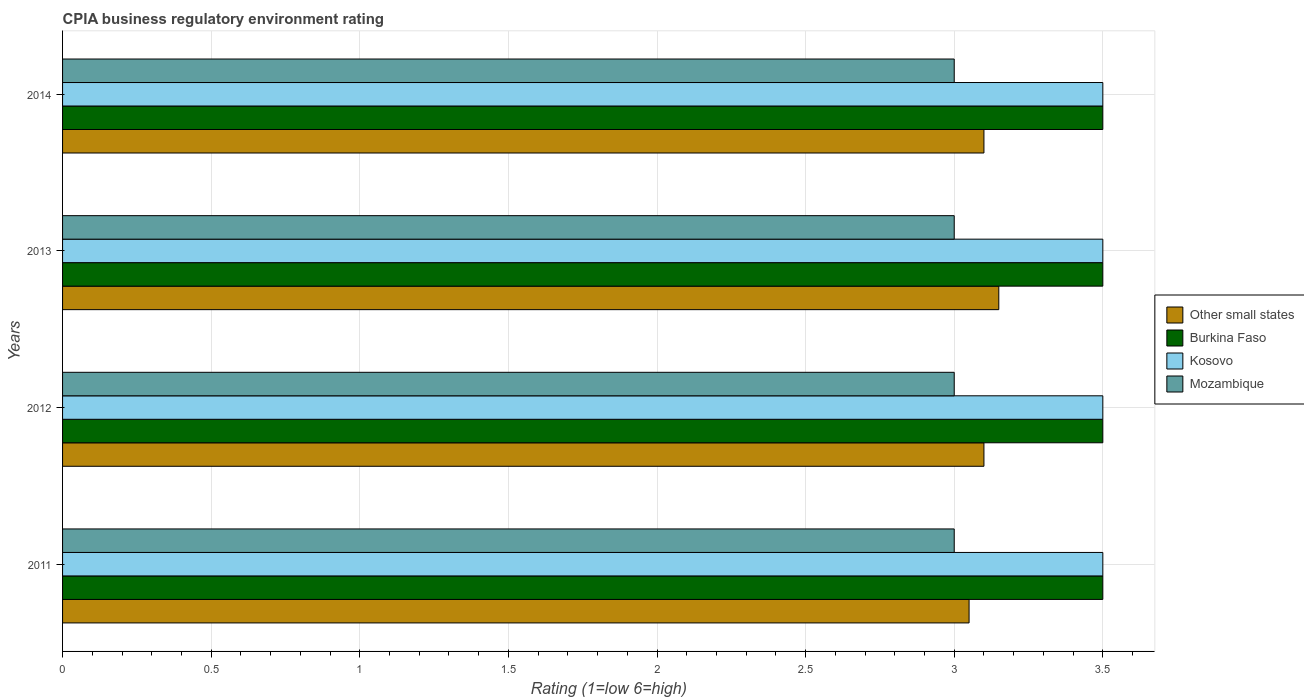How many different coloured bars are there?
Provide a short and direct response. 4. How many groups of bars are there?
Offer a terse response. 4. Are the number of bars per tick equal to the number of legend labels?
Your response must be concise. Yes. In how many cases, is the number of bars for a given year not equal to the number of legend labels?
Your answer should be compact. 0. Across all years, what is the maximum CPIA rating in Burkina Faso?
Your response must be concise. 3.5. Across all years, what is the minimum CPIA rating in Other small states?
Make the answer very short. 3.05. In which year was the CPIA rating in Mozambique maximum?
Your answer should be very brief. 2011. What is the total CPIA rating in Burkina Faso in the graph?
Your answer should be compact. 14. What is the difference between the CPIA rating in Burkina Faso in 2012 and that in 2013?
Keep it short and to the point. 0. What is the difference between the CPIA rating in Mozambique in 2011 and the CPIA rating in Other small states in 2012?
Offer a very short reply. -0.1. In the year 2011, what is the difference between the CPIA rating in Other small states and CPIA rating in Burkina Faso?
Offer a very short reply. -0.45. In how many years, is the CPIA rating in Mozambique greater than 1.1 ?
Your response must be concise. 4. Is the CPIA rating in Burkina Faso in 2012 less than that in 2013?
Offer a very short reply. No. Is the difference between the CPIA rating in Other small states in 2011 and 2014 greater than the difference between the CPIA rating in Burkina Faso in 2011 and 2014?
Give a very brief answer. No. What is the difference between the highest and the second highest CPIA rating in Burkina Faso?
Give a very brief answer. 0. What is the difference between the highest and the lowest CPIA rating in Kosovo?
Provide a short and direct response. 0. Is it the case that in every year, the sum of the CPIA rating in Other small states and CPIA rating in Burkina Faso is greater than the sum of CPIA rating in Kosovo and CPIA rating in Mozambique?
Ensure brevity in your answer.  No. What does the 2nd bar from the top in 2014 represents?
Keep it short and to the point. Kosovo. What does the 2nd bar from the bottom in 2011 represents?
Ensure brevity in your answer.  Burkina Faso. Is it the case that in every year, the sum of the CPIA rating in Burkina Faso and CPIA rating in Other small states is greater than the CPIA rating in Kosovo?
Your answer should be very brief. Yes. How many bars are there?
Offer a terse response. 16. Does the graph contain any zero values?
Ensure brevity in your answer.  No. Does the graph contain grids?
Keep it short and to the point. Yes. How are the legend labels stacked?
Provide a short and direct response. Vertical. What is the title of the graph?
Ensure brevity in your answer.  CPIA business regulatory environment rating. Does "San Marino" appear as one of the legend labels in the graph?
Offer a terse response. No. What is the Rating (1=low 6=high) in Other small states in 2011?
Keep it short and to the point. 3.05. What is the Rating (1=low 6=high) in Kosovo in 2011?
Your response must be concise. 3.5. What is the Rating (1=low 6=high) in Mozambique in 2011?
Offer a very short reply. 3. What is the Rating (1=low 6=high) of Other small states in 2012?
Make the answer very short. 3.1. What is the Rating (1=low 6=high) in Kosovo in 2012?
Provide a short and direct response. 3.5. What is the Rating (1=low 6=high) in Mozambique in 2012?
Offer a very short reply. 3. What is the Rating (1=low 6=high) of Other small states in 2013?
Offer a very short reply. 3.15. What is the Rating (1=low 6=high) of Kosovo in 2013?
Your answer should be compact. 3.5. What is the Rating (1=low 6=high) in Other small states in 2014?
Offer a very short reply. 3.1. What is the Rating (1=low 6=high) of Kosovo in 2014?
Your response must be concise. 3.5. Across all years, what is the maximum Rating (1=low 6=high) of Other small states?
Make the answer very short. 3.15. Across all years, what is the maximum Rating (1=low 6=high) of Burkina Faso?
Ensure brevity in your answer.  3.5. Across all years, what is the minimum Rating (1=low 6=high) in Other small states?
Give a very brief answer. 3.05. Across all years, what is the minimum Rating (1=low 6=high) in Mozambique?
Your answer should be compact. 3. What is the total Rating (1=low 6=high) in Other small states in the graph?
Your answer should be compact. 12.4. What is the total Rating (1=low 6=high) of Burkina Faso in the graph?
Your response must be concise. 14. What is the total Rating (1=low 6=high) in Kosovo in the graph?
Provide a succinct answer. 14. What is the total Rating (1=low 6=high) in Mozambique in the graph?
Offer a very short reply. 12. What is the difference between the Rating (1=low 6=high) of Other small states in 2011 and that in 2012?
Provide a short and direct response. -0.05. What is the difference between the Rating (1=low 6=high) in Burkina Faso in 2011 and that in 2012?
Make the answer very short. 0. What is the difference between the Rating (1=low 6=high) in Mozambique in 2011 and that in 2012?
Keep it short and to the point. 0. What is the difference between the Rating (1=low 6=high) in Other small states in 2011 and that in 2013?
Your answer should be compact. -0.1. What is the difference between the Rating (1=low 6=high) in Burkina Faso in 2011 and that in 2013?
Ensure brevity in your answer.  0. What is the difference between the Rating (1=low 6=high) of Other small states in 2011 and that in 2014?
Ensure brevity in your answer.  -0.05. What is the difference between the Rating (1=low 6=high) of Kosovo in 2011 and that in 2014?
Ensure brevity in your answer.  0. What is the difference between the Rating (1=low 6=high) of Other small states in 2012 and that in 2013?
Offer a terse response. -0.05. What is the difference between the Rating (1=low 6=high) of Kosovo in 2012 and that in 2013?
Your answer should be very brief. 0. What is the difference between the Rating (1=low 6=high) of Mozambique in 2012 and that in 2013?
Your answer should be compact. 0. What is the difference between the Rating (1=low 6=high) of Other small states in 2013 and that in 2014?
Provide a short and direct response. 0.05. What is the difference between the Rating (1=low 6=high) in Burkina Faso in 2013 and that in 2014?
Your answer should be compact. 0. What is the difference between the Rating (1=low 6=high) in Other small states in 2011 and the Rating (1=low 6=high) in Burkina Faso in 2012?
Your answer should be very brief. -0.45. What is the difference between the Rating (1=low 6=high) of Other small states in 2011 and the Rating (1=low 6=high) of Kosovo in 2012?
Your answer should be compact. -0.45. What is the difference between the Rating (1=low 6=high) of Burkina Faso in 2011 and the Rating (1=low 6=high) of Kosovo in 2012?
Offer a very short reply. 0. What is the difference between the Rating (1=low 6=high) in Kosovo in 2011 and the Rating (1=low 6=high) in Mozambique in 2012?
Your response must be concise. 0.5. What is the difference between the Rating (1=low 6=high) of Other small states in 2011 and the Rating (1=low 6=high) of Burkina Faso in 2013?
Make the answer very short. -0.45. What is the difference between the Rating (1=low 6=high) of Other small states in 2011 and the Rating (1=low 6=high) of Kosovo in 2013?
Provide a succinct answer. -0.45. What is the difference between the Rating (1=low 6=high) of Other small states in 2011 and the Rating (1=low 6=high) of Mozambique in 2013?
Provide a succinct answer. 0.05. What is the difference between the Rating (1=low 6=high) of Burkina Faso in 2011 and the Rating (1=low 6=high) of Mozambique in 2013?
Give a very brief answer. 0.5. What is the difference between the Rating (1=low 6=high) in Kosovo in 2011 and the Rating (1=low 6=high) in Mozambique in 2013?
Offer a terse response. 0.5. What is the difference between the Rating (1=low 6=high) in Other small states in 2011 and the Rating (1=low 6=high) in Burkina Faso in 2014?
Offer a very short reply. -0.45. What is the difference between the Rating (1=low 6=high) in Other small states in 2011 and the Rating (1=low 6=high) in Kosovo in 2014?
Your answer should be compact. -0.45. What is the difference between the Rating (1=low 6=high) in Other small states in 2011 and the Rating (1=low 6=high) in Mozambique in 2014?
Your answer should be compact. 0.05. What is the difference between the Rating (1=low 6=high) of Burkina Faso in 2011 and the Rating (1=low 6=high) of Kosovo in 2014?
Your answer should be compact. 0. What is the difference between the Rating (1=low 6=high) of Other small states in 2012 and the Rating (1=low 6=high) of Kosovo in 2013?
Give a very brief answer. -0.4. What is the difference between the Rating (1=low 6=high) of Other small states in 2012 and the Rating (1=low 6=high) of Mozambique in 2013?
Offer a very short reply. 0.1. What is the difference between the Rating (1=low 6=high) in Burkina Faso in 2012 and the Rating (1=low 6=high) in Kosovo in 2013?
Offer a terse response. 0. What is the difference between the Rating (1=low 6=high) in Other small states in 2012 and the Rating (1=low 6=high) in Kosovo in 2014?
Your answer should be compact. -0.4. What is the difference between the Rating (1=low 6=high) in Other small states in 2012 and the Rating (1=low 6=high) in Mozambique in 2014?
Give a very brief answer. 0.1. What is the difference between the Rating (1=low 6=high) in Burkina Faso in 2012 and the Rating (1=low 6=high) in Kosovo in 2014?
Provide a succinct answer. 0. What is the difference between the Rating (1=low 6=high) in Burkina Faso in 2012 and the Rating (1=low 6=high) in Mozambique in 2014?
Offer a terse response. 0.5. What is the difference between the Rating (1=low 6=high) in Other small states in 2013 and the Rating (1=low 6=high) in Burkina Faso in 2014?
Your answer should be very brief. -0.35. What is the difference between the Rating (1=low 6=high) of Other small states in 2013 and the Rating (1=low 6=high) of Kosovo in 2014?
Make the answer very short. -0.35. What is the difference between the Rating (1=low 6=high) in Other small states in 2013 and the Rating (1=low 6=high) in Mozambique in 2014?
Keep it short and to the point. 0.15. What is the difference between the Rating (1=low 6=high) of Burkina Faso in 2013 and the Rating (1=low 6=high) of Mozambique in 2014?
Keep it short and to the point. 0.5. What is the average Rating (1=low 6=high) of Other small states per year?
Your response must be concise. 3.1. What is the average Rating (1=low 6=high) in Burkina Faso per year?
Provide a succinct answer. 3.5. What is the average Rating (1=low 6=high) of Kosovo per year?
Offer a very short reply. 3.5. What is the average Rating (1=low 6=high) in Mozambique per year?
Give a very brief answer. 3. In the year 2011, what is the difference between the Rating (1=low 6=high) of Other small states and Rating (1=low 6=high) of Burkina Faso?
Keep it short and to the point. -0.45. In the year 2011, what is the difference between the Rating (1=low 6=high) in Other small states and Rating (1=low 6=high) in Kosovo?
Keep it short and to the point. -0.45. In the year 2011, what is the difference between the Rating (1=low 6=high) in Burkina Faso and Rating (1=low 6=high) in Kosovo?
Give a very brief answer. 0. In the year 2011, what is the difference between the Rating (1=low 6=high) in Burkina Faso and Rating (1=low 6=high) in Mozambique?
Your answer should be very brief. 0.5. In the year 2012, what is the difference between the Rating (1=low 6=high) of Other small states and Rating (1=low 6=high) of Kosovo?
Give a very brief answer. -0.4. In the year 2012, what is the difference between the Rating (1=low 6=high) in Other small states and Rating (1=low 6=high) in Mozambique?
Keep it short and to the point. 0.1. In the year 2012, what is the difference between the Rating (1=low 6=high) of Kosovo and Rating (1=low 6=high) of Mozambique?
Provide a short and direct response. 0.5. In the year 2013, what is the difference between the Rating (1=low 6=high) of Other small states and Rating (1=low 6=high) of Burkina Faso?
Offer a terse response. -0.35. In the year 2013, what is the difference between the Rating (1=low 6=high) of Other small states and Rating (1=low 6=high) of Kosovo?
Give a very brief answer. -0.35. In the year 2013, what is the difference between the Rating (1=low 6=high) of Other small states and Rating (1=low 6=high) of Mozambique?
Offer a terse response. 0.15. In the year 2013, what is the difference between the Rating (1=low 6=high) in Burkina Faso and Rating (1=low 6=high) in Kosovo?
Keep it short and to the point. 0. In the year 2013, what is the difference between the Rating (1=low 6=high) in Kosovo and Rating (1=low 6=high) in Mozambique?
Provide a succinct answer. 0.5. In the year 2014, what is the difference between the Rating (1=low 6=high) of Other small states and Rating (1=low 6=high) of Burkina Faso?
Keep it short and to the point. -0.4. In the year 2014, what is the difference between the Rating (1=low 6=high) of Other small states and Rating (1=low 6=high) of Kosovo?
Ensure brevity in your answer.  -0.4. In the year 2014, what is the difference between the Rating (1=low 6=high) of Burkina Faso and Rating (1=low 6=high) of Kosovo?
Provide a short and direct response. 0. In the year 2014, what is the difference between the Rating (1=low 6=high) in Burkina Faso and Rating (1=low 6=high) in Mozambique?
Ensure brevity in your answer.  0.5. In the year 2014, what is the difference between the Rating (1=low 6=high) in Kosovo and Rating (1=low 6=high) in Mozambique?
Offer a terse response. 0.5. What is the ratio of the Rating (1=low 6=high) in Other small states in 2011 to that in 2012?
Offer a very short reply. 0.98. What is the ratio of the Rating (1=low 6=high) in Burkina Faso in 2011 to that in 2012?
Provide a short and direct response. 1. What is the ratio of the Rating (1=low 6=high) in Kosovo in 2011 to that in 2012?
Give a very brief answer. 1. What is the ratio of the Rating (1=low 6=high) in Mozambique in 2011 to that in 2012?
Ensure brevity in your answer.  1. What is the ratio of the Rating (1=low 6=high) in Other small states in 2011 to that in 2013?
Your answer should be compact. 0.97. What is the ratio of the Rating (1=low 6=high) of Kosovo in 2011 to that in 2013?
Ensure brevity in your answer.  1. What is the ratio of the Rating (1=low 6=high) of Mozambique in 2011 to that in 2013?
Make the answer very short. 1. What is the ratio of the Rating (1=low 6=high) in Other small states in 2011 to that in 2014?
Your response must be concise. 0.98. What is the ratio of the Rating (1=low 6=high) of Kosovo in 2011 to that in 2014?
Keep it short and to the point. 1. What is the ratio of the Rating (1=low 6=high) in Other small states in 2012 to that in 2013?
Provide a succinct answer. 0.98. What is the ratio of the Rating (1=low 6=high) in Mozambique in 2012 to that in 2013?
Make the answer very short. 1. What is the ratio of the Rating (1=low 6=high) in Burkina Faso in 2012 to that in 2014?
Offer a very short reply. 1. What is the ratio of the Rating (1=low 6=high) of Kosovo in 2012 to that in 2014?
Offer a very short reply. 1. What is the ratio of the Rating (1=low 6=high) of Mozambique in 2012 to that in 2014?
Keep it short and to the point. 1. What is the ratio of the Rating (1=low 6=high) of Other small states in 2013 to that in 2014?
Provide a short and direct response. 1.02. What is the ratio of the Rating (1=low 6=high) of Kosovo in 2013 to that in 2014?
Offer a terse response. 1. What is the ratio of the Rating (1=low 6=high) of Mozambique in 2013 to that in 2014?
Give a very brief answer. 1. What is the difference between the highest and the second highest Rating (1=low 6=high) in Mozambique?
Your answer should be compact. 0. What is the difference between the highest and the lowest Rating (1=low 6=high) of Other small states?
Provide a short and direct response. 0.1. What is the difference between the highest and the lowest Rating (1=low 6=high) in Burkina Faso?
Keep it short and to the point. 0. What is the difference between the highest and the lowest Rating (1=low 6=high) in Kosovo?
Your response must be concise. 0. 